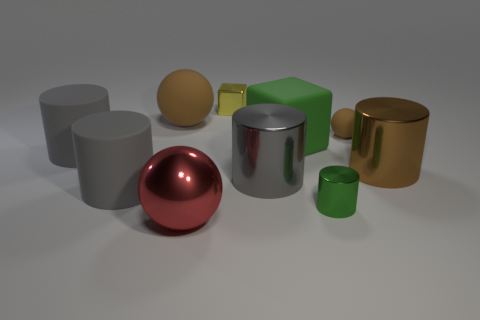What number of small purple objects are there?
Your response must be concise. 0. What material is the green object in front of the big cylinder that is behind the big brown shiny cylinder to the right of the metal block?
Give a very brief answer. Metal. What number of large gray metal objects are behind the big brown object that is in front of the tiny rubber ball?
Ensure brevity in your answer.  0. What color is the other thing that is the same shape as the yellow shiny thing?
Provide a short and direct response. Green. Does the tiny yellow thing have the same material as the large cube?
Offer a terse response. No. How many cubes are either tiny yellow shiny things or brown matte objects?
Keep it short and to the point. 1. There is a rubber ball that is behind the sphere on the right side of the big red sphere that is in front of the small green shiny thing; how big is it?
Keep it short and to the point. Large. There is another brown rubber thing that is the same shape as the small brown matte thing; what size is it?
Your response must be concise. Large. What number of gray rubber cylinders are to the left of the big rubber cube?
Give a very brief answer. 2. There is a small shiny thing in front of the brown metallic cylinder; does it have the same color as the big matte cube?
Give a very brief answer. Yes. 